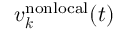<formula> <loc_0><loc_0><loc_500><loc_500>\boldsymbol v _ { \boldsymbol k } ^ { n o n l o c a l } ( t )</formula> 